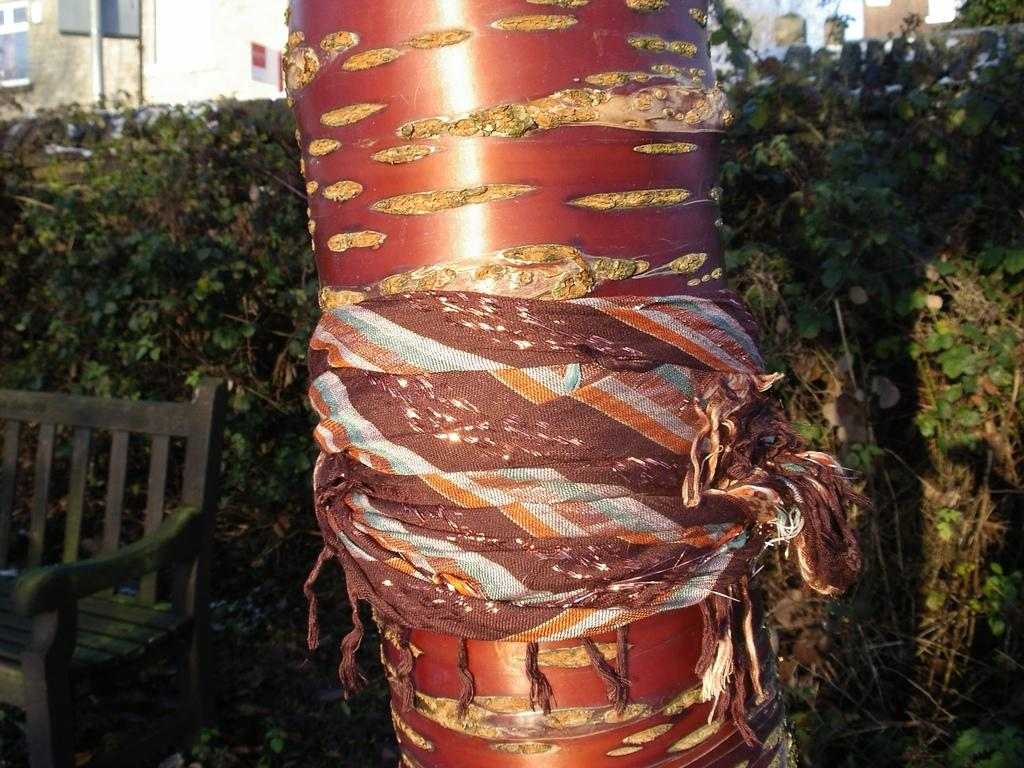What is attached to the pole in the image? There is a pole with cloth in the image. What can be seen in the background of the image? There are many plants in the background of the image. What is located on the left side of the image? There is a bench on the left side of the image. What is at the top of the pole in the image? There is a pole with a board at the top of the image. What structure is visible at the top of the image? There is a wall visible at the top of the image. How many clocks are hanging on the wall in the image? There are no clocks visible in the image; only a wall is present at the top. What type of rail is used for the pole with cloth in the image? There is no rail mentioned or visible in the image; it only features a pole with cloth. 